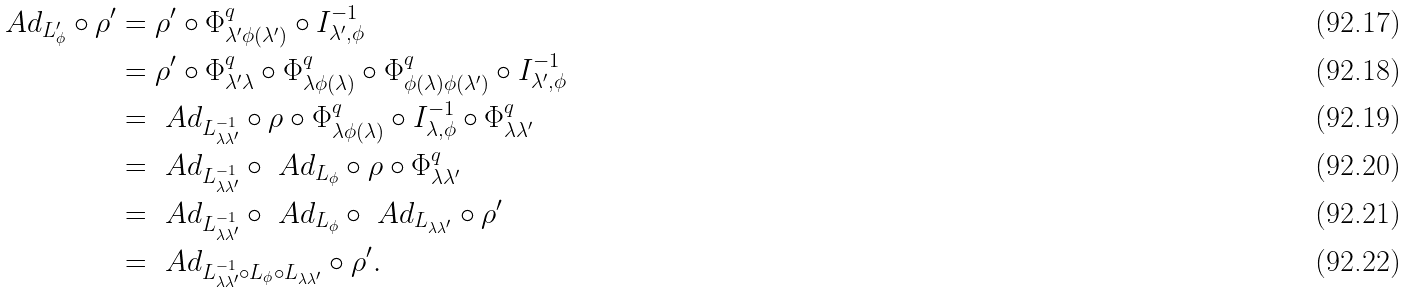<formula> <loc_0><loc_0><loc_500><loc_500>\ A d _ { L _ { \phi } ^ { \prime } } \circ \rho ^ { \prime } & = \rho ^ { \prime } \circ \Phi _ { \lambda ^ { \prime } \phi ( \lambda ^ { \prime } ) } ^ { q } \circ I _ { \lambda ^ { \prime } , \phi } ^ { - 1 } \\ & = \rho ^ { \prime } \circ \Phi _ { \lambda ^ { \prime } \lambda } ^ { q } \circ \Phi _ { \lambda \phi ( \lambda ) } ^ { q } \circ \Phi _ { \phi ( \lambda ) \phi ( \lambda ^ { \prime } ) } ^ { q } \circ I _ { \lambda ^ { \prime } , \phi } ^ { - 1 } \\ & = \ A d _ { L _ { \lambda \lambda ^ { \prime } } ^ { - 1 } } \circ \rho \circ \Phi _ { \lambda \phi ( \lambda ) } ^ { q } \circ I _ { \lambda , \phi } ^ { - 1 } \circ \Phi _ { \lambda \lambda ^ { \prime } } ^ { q } \\ & = \ A d _ { L _ { \lambda \lambda ^ { \prime } } ^ { - 1 } } \circ \ A d _ { L _ { \phi } } \circ \rho \circ \Phi _ { \lambda \lambda ^ { \prime } } ^ { q } \\ & = \ A d _ { L _ { \lambda \lambda ^ { \prime } } ^ { - 1 } } \circ \ A d _ { L _ { \phi } } \circ \ A d _ { L _ { \lambda \lambda ^ { \prime } } } \circ \rho ^ { \prime } \\ & = \ A d _ { L _ { \lambda \lambda ^ { \prime } } ^ { - 1 } \circ L _ { \phi } \circ L _ { \lambda \lambda ^ { \prime } } } \circ \rho ^ { \prime } .</formula> 